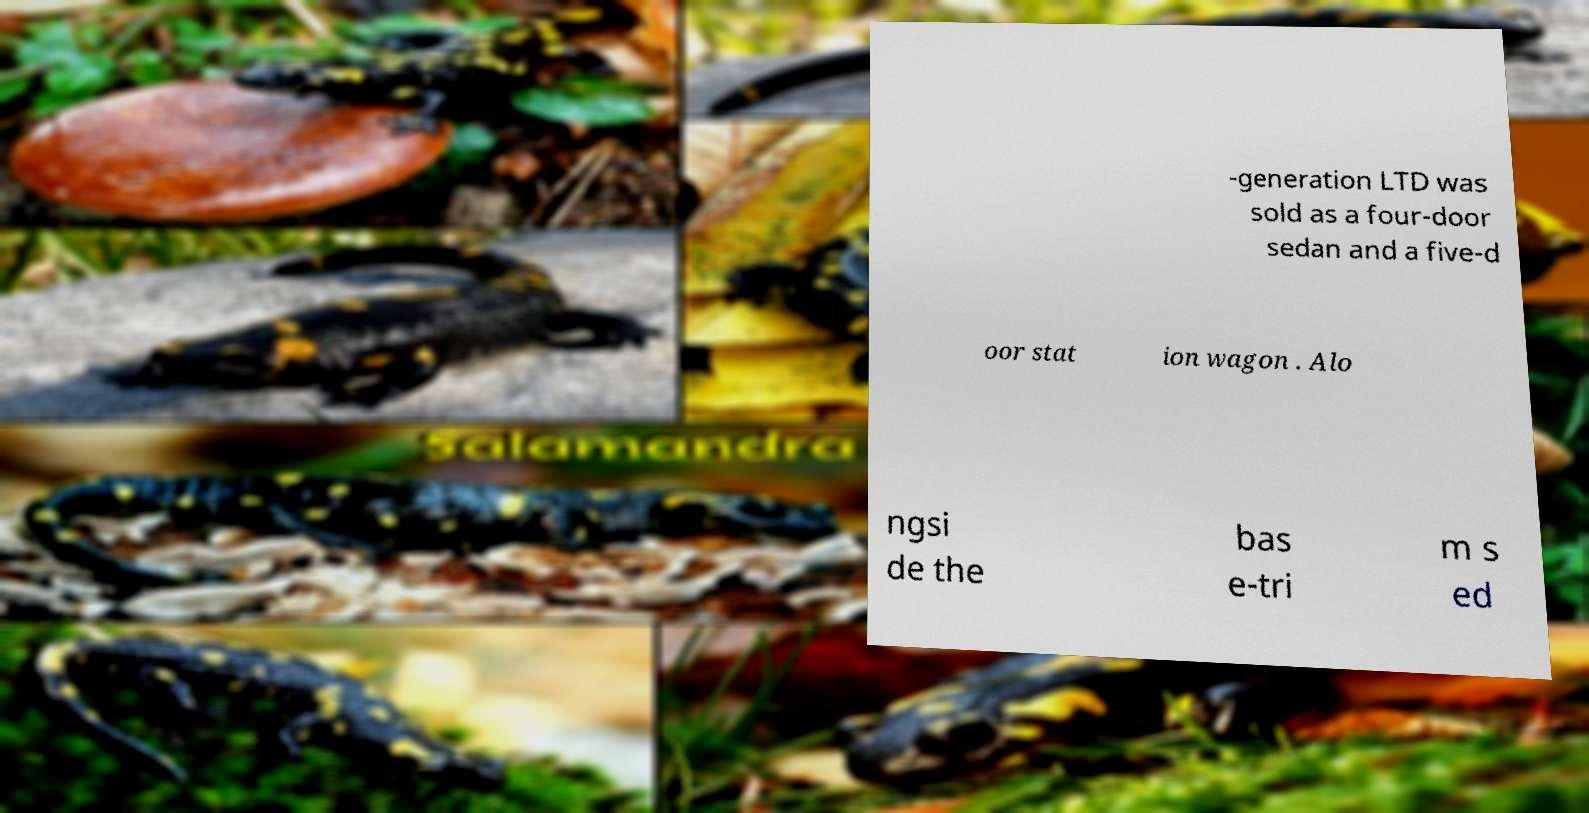Can you accurately transcribe the text from the provided image for me? -generation LTD was sold as a four-door sedan and a five-d oor stat ion wagon . Alo ngsi de the bas e-tri m s ed 